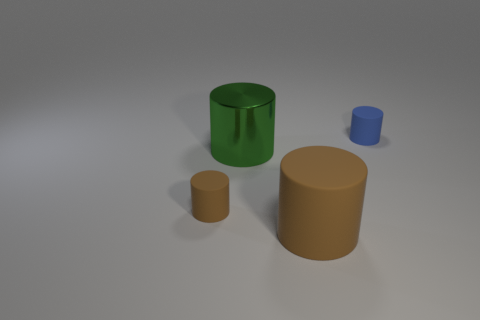How many metal objects are the same color as the large rubber thing?
Give a very brief answer. 0. Is the number of cylinders less than the number of brown matte cylinders?
Your answer should be very brief. No. Do the small brown cylinder and the tiny blue cylinder have the same material?
Make the answer very short. Yes. How many other objects are there of the same size as the blue object?
Ensure brevity in your answer.  1. The matte object that is behind the brown matte object that is on the left side of the big green cylinder is what color?
Provide a short and direct response. Blue. What number of other things are there of the same shape as the big brown thing?
Provide a succinct answer. 3. Are there any tiny cylinders that have the same material as the small blue object?
Your response must be concise. Yes. What material is the brown cylinder that is the same size as the green object?
Your answer should be very brief. Rubber. There is a thing that is right of the object in front of the brown cylinder behind the big brown thing; what is its color?
Give a very brief answer. Blue. There is a brown rubber thing on the left side of the big matte thing; is it the same shape as the large object that is behind the large brown cylinder?
Offer a terse response. Yes. 